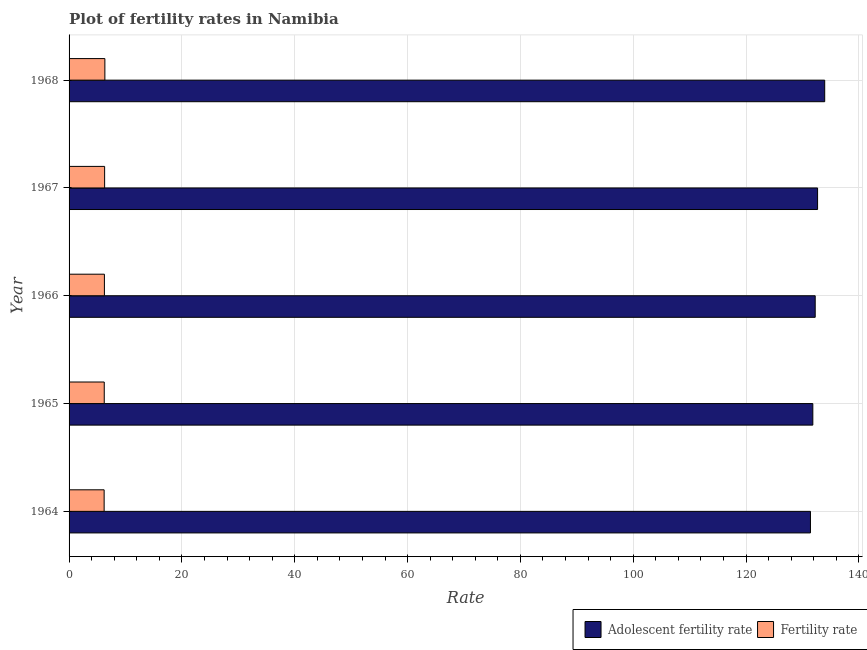How many groups of bars are there?
Make the answer very short. 5. Are the number of bars on each tick of the Y-axis equal?
Provide a short and direct response. Yes. How many bars are there on the 3rd tick from the bottom?
Offer a terse response. 2. What is the label of the 2nd group of bars from the top?
Your response must be concise. 1967. In how many cases, is the number of bars for a given year not equal to the number of legend labels?
Offer a very short reply. 0. What is the adolescent fertility rate in 1964?
Offer a terse response. 131.41. Across all years, what is the maximum fertility rate?
Provide a short and direct response. 6.35. Across all years, what is the minimum adolescent fertility rate?
Make the answer very short. 131.41. In which year was the adolescent fertility rate maximum?
Provide a succinct answer. 1968. In which year was the fertility rate minimum?
Your answer should be very brief. 1964. What is the total adolescent fertility rate in the graph?
Your response must be concise. 662.13. What is the difference between the fertility rate in 1964 and that in 1965?
Ensure brevity in your answer.  -0.02. What is the difference between the adolescent fertility rate in 1966 and the fertility rate in 1968?
Make the answer very short. 125.91. What is the average adolescent fertility rate per year?
Provide a short and direct response. 132.43. In the year 1964, what is the difference between the adolescent fertility rate and fertility rate?
Keep it short and to the point. 125.2. In how many years, is the fertility rate greater than 104 ?
Keep it short and to the point. 0. What is the difference between the highest and the second highest adolescent fertility rate?
Ensure brevity in your answer.  1.26. What is the difference between the highest and the lowest adolescent fertility rate?
Give a very brief answer. 2.53. In how many years, is the adolescent fertility rate greater than the average adolescent fertility rate taken over all years?
Your answer should be compact. 2. Is the sum of the adolescent fertility rate in 1965 and 1968 greater than the maximum fertility rate across all years?
Offer a terse response. Yes. What does the 2nd bar from the top in 1967 represents?
Offer a terse response. Adolescent fertility rate. What does the 1st bar from the bottom in 1965 represents?
Provide a succinct answer. Adolescent fertility rate. How many bars are there?
Offer a very short reply. 10. Are all the bars in the graph horizontal?
Provide a short and direct response. Yes. How many years are there in the graph?
Your answer should be very brief. 5. What is the difference between two consecutive major ticks on the X-axis?
Offer a terse response. 20. Are the values on the major ticks of X-axis written in scientific E-notation?
Offer a terse response. No. Does the graph contain any zero values?
Provide a short and direct response. No. Does the graph contain grids?
Make the answer very short. Yes. Where does the legend appear in the graph?
Your response must be concise. Bottom right. How many legend labels are there?
Give a very brief answer. 2. What is the title of the graph?
Give a very brief answer. Plot of fertility rates in Namibia. What is the label or title of the X-axis?
Provide a short and direct response. Rate. What is the label or title of the Y-axis?
Your answer should be compact. Year. What is the Rate of Adolescent fertility rate in 1964?
Your response must be concise. 131.41. What is the Rate in Fertility rate in 1964?
Make the answer very short. 6.22. What is the Rate in Adolescent fertility rate in 1965?
Offer a terse response. 131.84. What is the Rate of Fertility rate in 1965?
Offer a terse response. 6.24. What is the Rate of Adolescent fertility rate in 1966?
Your answer should be compact. 132.26. What is the Rate of Fertility rate in 1966?
Offer a terse response. 6.26. What is the Rate in Adolescent fertility rate in 1967?
Ensure brevity in your answer.  132.68. What is the Rate of Fertility rate in 1967?
Ensure brevity in your answer.  6.3. What is the Rate in Adolescent fertility rate in 1968?
Offer a very short reply. 133.94. What is the Rate in Fertility rate in 1968?
Offer a terse response. 6.35. Across all years, what is the maximum Rate of Adolescent fertility rate?
Your response must be concise. 133.94. Across all years, what is the maximum Rate of Fertility rate?
Your answer should be compact. 6.35. Across all years, what is the minimum Rate of Adolescent fertility rate?
Offer a terse response. 131.41. Across all years, what is the minimum Rate in Fertility rate?
Keep it short and to the point. 6.22. What is the total Rate of Adolescent fertility rate in the graph?
Offer a terse response. 662.13. What is the total Rate of Fertility rate in the graph?
Make the answer very short. 31.36. What is the difference between the Rate of Adolescent fertility rate in 1964 and that in 1965?
Your answer should be very brief. -0.42. What is the difference between the Rate in Fertility rate in 1964 and that in 1965?
Provide a short and direct response. -0.02. What is the difference between the Rate in Adolescent fertility rate in 1964 and that in 1966?
Your answer should be compact. -0.84. What is the difference between the Rate in Fertility rate in 1964 and that in 1966?
Offer a terse response. -0.05. What is the difference between the Rate in Adolescent fertility rate in 1964 and that in 1967?
Make the answer very short. -1.26. What is the difference between the Rate in Fertility rate in 1964 and that in 1967?
Offer a very short reply. -0.09. What is the difference between the Rate of Adolescent fertility rate in 1964 and that in 1968?
Provide a succinct answer. -2.53. What is the difference between the Rate of Fertility rate in 1964 and that in 1968?
Offer a terse response. -0.13. What is the difference between the Rate in Adolescent fertility rate in 1965 and that in 1966?
Provide a succinct answer. -0.42. What is the difference between the Rate in Fertility rate in 1965 and that in 1966?
Offer a terse response. -0.03. What is the difference between the Rate in Adolescent fertility rate in 1965 and that in 1967?
Offer a terse response. -0.84. What is the difference between the Rate in Fertility rate in 1965 and that in 1967?
Give a very brief answer. -0.07. What is the difference between the Rate in Adolescent fertility rate in 1965 and that in 1968?
Give a very brief answer. -2.11. What is the difference between the Rate of Fertility rate in 1965 and that in 1968?
Your response must be concise. -0.11. What is the difference between the Rate in Adolescent fertility rate in 1966 and that in 1967?
Offer a very short reply. -0.42. What is the difference between the Rate in Fertility rate in 1966 and that in 1967?
Your answer should be compact. -0.04. What is the difference between the Rate of Adolescent fertility rate in 1966 and that in 1968?
Make the answer very short. -1.68. What is the difference between the Rate of Fertility rate in 1966 and that in 1968?
Provide a short and direct response. -0.08. What is the difference between the Rate of Adolescent fertility rate in 1967 and that in 1968?
Give a very brief answer. -1.26. What is the difference between the Rate in Fertility rate in 1967 and that in 1968?
Your response must be concise. -0.05. What is the difference between the Rate in Adolescent fertility rate in 1964 and the Rate in Fertility rate in 1965?
Your answer should be very brief. 125.18. What is the difference between the Rate in Adolescent fertility rate in 1964 and the Rate in Fertility rate in 1966?
Provide a short and direct response. 125.15. What is the difference between the Rate of Adolescent fertility rate in 1964 and the Rate of Fertility rate in 1967?
Keep it short and to the point. 125.11. What is the difference between the Rate in Adolescent fertility rate in 1964 and the Rate in Fertility rate in 1968?
Provide a short and direct response. 125.07. What is the difference between the Rate of Adolescent fertility rate in 1965 and the Rate of Fertility rate in 1966?
Your answer should be compact. 125.57. What is the difference between the Rate of Adolescent fertility rate in 1965 and the Rate of Fertility rate in 1967?
Provide a short and direct response. 125.53. What is the difference between the Rate in Adolescent fertility rate in 1965 and the Rate in Fertility rate in 1968?
Make the answer very short. 125.49. What is the difference between the Rate in Adolescent fertility rate in 1966 and the Rate in Fertility rate in 1967?
Your answer should be compact. 125.96. What is the difference between the Rate of Adolescent fertility rate in 1966 and the Rate of Fertility rate in 1968?
Ensure brevity in your answer.  125.91. What is the difference between the Rate of Adolescent fertility rate in 1967 and the Rate of Fertility rate in 1968?
Offer a terse response. 126.33. What is the average Rate of Adolescent fertility rate per year?
Make the answer very short. 132.43. What is the average Rate in Fertility rate per year?
Provide a short and direct response. 6.27. In the year 1964, what is the difference between the Rate in Adolescent fertility rate and Rate in Fertility rate?
Provide a short and direct response. 125.2. In the year 1965, what is the difference between the Rate in Adolescent fertility rate and Rate in Fertility rate?
Provide a succinct answer. 125.6. In the year 1966, what is the difference between the Rate in Adolescent fertility rate and Rate in Fertility rate?
Make the answer very short. 125.99. In the year 1967, what is the difference between the Rate of Adolescent fertility rate and Rate of Fertility rate?
Make the answer very short. 126.38. In the year 1968, what is the difference between the Rate of Adolescent fertility rate and Rate of Fertility rate?
Provide a short and direct response. 127.59. What is the ratio of the Rate in Adolescent fertility rate in 1964 to that in 1965?
Provide a succinct answer. 1. What is the ratio of the Rate of Fertility rate in 1964 to that in 1965?
Make the answer very short. 1. What is the ratio of the Rate in Adolescent fertility rate in 1964 to that in 1967?
Provide a short and direct response. 0.99. What is the ratio of the Rate of Fertility rate in 1964 to that in 1967?
Your response must be concise. 0.99. What is the ratio of the Rate in Adolescent fertility rate in 1964 to that in 1968?
Your answer should be compact. 0.98. What is the ratio of the Rate of Fertility rate in 1964 to that in 1968?
Ensure brevity in your answer.  0.98. What is the ratio of the Rate of Adolescent fertility rate in 1965 to that in 1966?
Make the answer very short. 1. What is the ratio of the Rate in Fertility rate in 1965 to that in 1966?
Offer a very short reply. 1. What is the ratio of the Rate of Adolescent fertility rate in 1965 to that in 1967?
Give a very brief answer. 0.99. What is the ratio of the Rate in Adolescent fertility rate in 1965 to that in 1968?
Give a very brief answer. 0.98. What is the ratio of the Rate in Fertility rate in 1965 to that in 1968?
Make the answer very short. 0.98. What is the ratio of the Rate of Adolescent fertility rate in 1966 to that in 1967?
Your answer should be very brief. 1. What is the ratio of the Rate of Fertility rate in 1966 to that in 1967?
Your answer should be very brief. 0.99. What is the ratio of the Rate of Adolescent fertility rate in 1966 to that in 1968?
Provide a short and direct response. 0.99. What is the ratio of the Rate of Adolescent fertility rate in 1967 to that in 1968?
Your answer should be very brief. 0.99. What is the ratio of the Rate of Fertility rate in 1967 to that in 1968?
Your response must be concise. 0.99. What is the difference between the highest and the second highest Rate of Adolescent fertility rate?
Give a very brief answer. 1.26. What is the difference between the highest and the second highest Rate in Fertility rate?
Your answer should be compact. 0.05. What is the difference between the highest and the lowest Rate of Adolescent fertility rate?
Your response must be concise. 2.53. What is the difference between the highest and the lowest Rate in Fertility rate?
Provide a succinct answer. 0.13. 